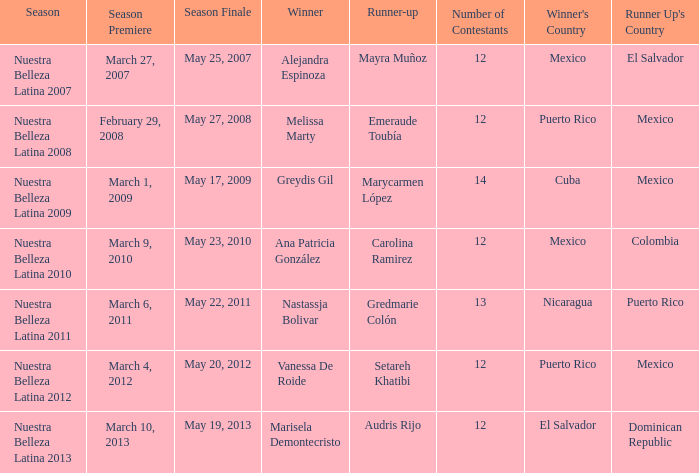What season had mexico as the runner up with melissa marty winning? Nuestra Belleza Latina 2008. Help me parse the entirety of this table. {'header': ['Season', 'Season Premiere', 'Season Finale', 'Winner', 'Runner-up', 'Number of Contestants', "Winner's Country", "Runner Up's Country"], 'rows': [['Nuestra Belleza Latina 2007', 'March 27, 2007', 'May 25, 2007', 'Alejandra Espinoza', 'Mayra Muñoz', '12', 'Mexico', 'El Salvador'], ['Nuestra Belleza Latina 2008', 'February 29, 2008', 'May 27, 2008', 'Melissa Marty', 'Emeraude Toubía', '12', 'Puerto Rico', 'Mexico'], ['Nuestra Belleza Latina 2009', 'March 1, 2009', 'May 17, 2009', 'Greydis Gil', 'Marycarmen López', '14', 'Cuba', 'Mexico'], ['Nuestra Belleza Latina 2010', 'March 9, 2010', 'May 23, 2010', 'Ana Patricia González', 'Carolina Ramirez', '12', 'Mexico', 'Colombia'], ['Nuestra Belleza Latina 2011', 'March 6, 2011', 'May 22, 2011', 'Nastassja Bolivar', 'Gredmarie Colón', '13', 'Nicaragua', 'Puerto Rico'], ['Nuestra Belleza Latina 2012', 'March 4, 2012', 'May 20, 2012', 'Vanessa De Roide', 'Setareh Khatibi', '12', 'Puerto Rico', 'Mexico'], ['Nuestra Belleza Latina 2013', 'March 10, 2013', 'May 19, 2013', 'Marisela Demontecristo', 'Audris Rijo', '12', 'El Salvador', 'Dominican Republic']]} 